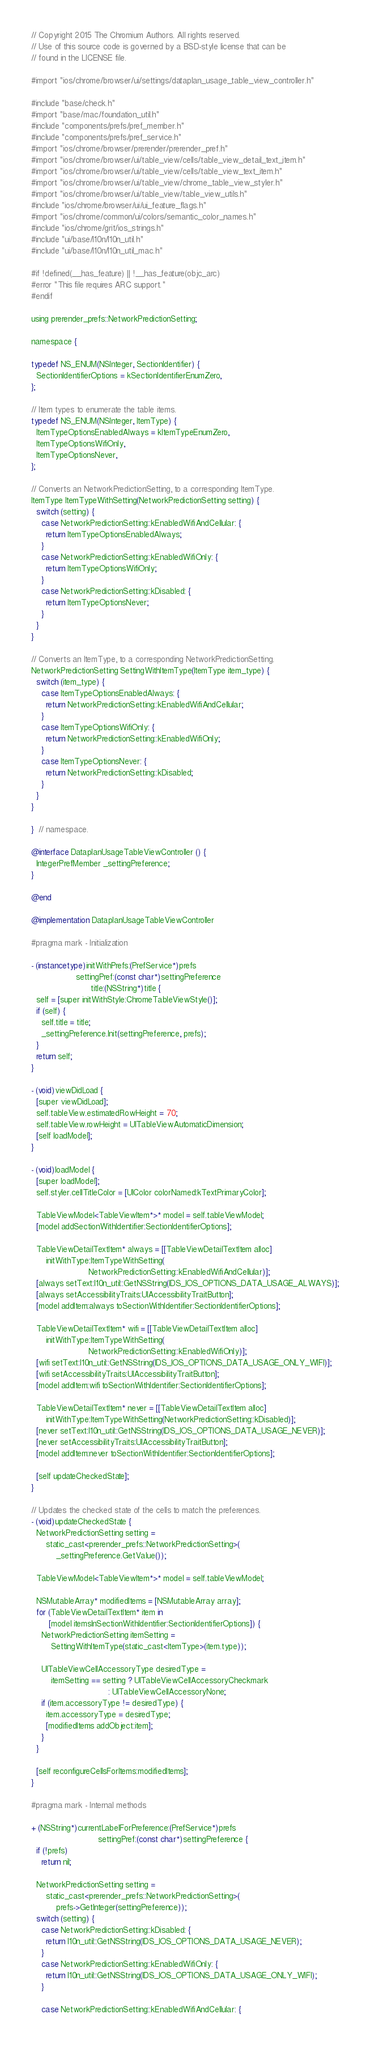<code> <loc_0><loc_0><loc_500><loc_500><_ObjectiveC_>// Copyright 2015 The Chromium Authors. All rights reserved.
// Use of this source code is governed by a BSD-style license that can be
// found in the LICENSE file.

#import "ios/chrome/browser/ui/settings/dataplan_usage_table_view_controller.h"

#include "base/check.h"
#import "base/mac/foundation_util.h"
#include "components/prefs/pref_member.h"
#include "components/prefs/pref_service.h"
#import "ios/chrome/browser/prerender/prerender_pref.h"
#import "ios/chrome/browser/ui/table_view/cells/table_view_detail_text_item.h"
#import "ios/chrome/browser/ui/table_view/cells/table_view_text_item.h"
#import "ios/chrome/browser/ui/table_view/chrome_table_view_styler.h"
#import "ios/chrome/browser/ui/table_view/table_view_utils.h"
#include "ios/chrome/browser/ui/ui_feature_flags.h"
#import "ios/chrome/common/ui/colors/semantic_color_names.h"
#include "ios/chrome/grit/ios_strings.h"
#include "ui/base/l10n/l10n_util.h"
#include "ui/base/l10n/l10n_util_mac.h"

#if !defined(__has_feature) || !__has_feature(objc_arc)
#error "This file requires ARC support."
#endif

using prerender_prefs::NetworkPredictionSetting;

namespace {

typedef NS_ENUM(NSInteger, SectionIdentifier) {
  SectionIdentifierOptions = kSectionIdentifierEnumZero,
};

// Item types to enumerate the table items.
typedef NS_ENUM(NSInteger, ItemType) {
  ItemTypeOptionsEnabledAlways = kItemTypeEnumZero,
  ItemTypeOptionsWifiOnly,
  ItemTypeOptionsNever,
};

// Converts an NetworkPredictionSetting, to a corresponding ItemType.
ItemType ItemTypeWithSetting(NetworkPredictionSetting setting) {
  switch (setting) {
    case NetworkPredictionSetting::kEnabledWifiAndCellular: {
      return ItemTypeOptionsEnabledAlways;
    }
    case NetworkPredictionSetting::kEnabledWifiOnly: {
      return ItemTypeOptionsWifiOnly;
    }
    case NetworkPredictionSetting::kDisabled: {
      return ItemTypeOptionsNever;
    }
  }
}

// Converts an ItemType, to a corresponding NetworkPredictionSetting.
NetworkPredictionSetting SettingWithItemType(ItemType item_type) {
  switch (item_type) {
    case ItemTypeOptionsEnabledAlways: {
      return NetworkPredictionSetting::kEnabledWifiAndCellular;
    }
    case ItemTypeOptionsWifiOnly: {
      return NetworkPredictionSetting::kEnabledWifiOnly;
    }
    case ItemTypeOptionsNever: {
      return NetworkPredictionSetting::kDisabled;
    }
  }
}

}  // namespace.

@interface DataplanUsageTableViewController () {
  IntegerPrefMember _settingPreference;
}

@end

@implementation DataplanUsageTableViewController

#pragma mark - Initialization

- (instancetype)initWithPrefs:(PrefService*)prefs
                  settingPref:(const char*)settingPreference
                        title:(NSString*)title {
  self = [super initWithStyle:ChromeTableViewStyle()];
  if (self) {
    self.title = title;
    _settingPreference.Init(settingPreference, prefs);
  }
  return self;
}

- (void)viewDidLoad {
  [super viewDidLoad];
  self.tableView.estimatedRowHeight = 70;
  self.tableView.rowHeight = UITableViewAutomaticDimension;
  [self loadModel];
}

- (void)loadModel {
  [super loadModel];
  self.styler.cellTitleColor = [UIColor colorNamed:kTextPrimaryColor];

  TableViewModel<TableViewItem*>* model = self.tableViewModel;
  [model addSectionWithIdentifier:SectionIdentifierOptions];

  TableViewDetailTextItem* always = [[TableViewDetailTextItem alloc]
      initWithType:ItemTypeWithSetting(
                       NetworkPredictionSetting::kEnabledWifiAndCellular)];
  [always setText:l10n_util::GetNSString(IDS_IOS_OPTIONS_DATA_USAGE_ALWAYS)];
  [always setAccessibilityTraits:UIAccessibilityTraitButton];
  [model addItem:always toSectionWithIdentifier:SectionIdentifierOptions];

  TableViewDetailTextItem* wifi = [[TableViewDetailTextItem alloc]
      initWithType:ItemTypeWithSetting(
                       NetworkPredictionSetting::kEnabledWifiOnly)];
  [wifi setText:l10n_util::GetNSString(IDS_IOS_OPTIONS_DATA_USAGE_ONLY_WIFI)];
  [wifi setAccessibilityTraits:UIAccessibilityTraitButton];
  [model addItem:wifi toSectionWithIdentifier:SectionIdentifierOptions];

  TableViewDetailTextItem* never = [[TableViewDetailTextItem alloc]
      initWithType:ItemTypeWithSetting(NetworkPredictionSetting::kDisabled)];
  [never setText:l10n_util::GetNSString(IDS_IOS_OPTIONS_DATA_USAGE_NEVER)];
  [never setAccessibilityTraits:UIAccessibilityTraitButton];
  [model addItem:never toSectionWithIdentifier:SectionIdentifierOptions];

  [self updateCheckedState];
}

// Updates the checked state of the cells to match the preferences.
- (void)updateCheckedState {
  NetworkPredictionSetting setting =
      static_cast<prerender_prefs::NetworkPredictionSetting>(
          _settingPreference.GetValue());

  TableViewModel<TableViewItem*>* model = self.tableViewModel;

  NSMutableArray* modifiedItems = [NSMutableArray array];
  for (TableViewDetailTextItem* item in
       [model itemsInSectionWithIdentifier:SectionIdentifierOptions]) {
    NetworkPredictionSetting itemSetting =
        SettingWithItemType(static_cast<ItemType>(item.type));

    UITableViewCellAccessoryType desiredType =
        itemSetting == setting ? UITableViewCellAccessoryCheckmark
                               : UITableViewCellAccessoryNone;
    if (item.accessoryType != desiredType) {
      item.accessoryType = desiredType;
      [modifiedItems addObject:item];
    }
  }

  [self reconfigureCellsForItems:modifiedItems];
}

#pragma mark - Internal methods

+ (NSString*)currentLabelForPreference:(PrefService*)prefs
                           settingPref:(const char*)settingPreference {
  if (!prefs)
    return nil;

  NetworkPredictionSetting setting =
      static_cast<prerender_prefs::NetworkPredictionSetting>(
          prefs->GetInteger(settingPreference));
  switch (setting) {
    case NetworkPredictionSetting::kDisabled: {
      return l10n_util::GetNSString(IDS_IOS_OPTIONS_DATA_USAGE_NEVER);
    }
    case NetworkPredictionSetting::kEnabledWifiOnly: {
      return l10n_util::GetNSString(IDS_IOS_OPTIONS_DATA_USAGE_ONLY_WIFI);
    }

    case NetworkPredictionSetting::kEnabledWifiAndCellular: {</code> 